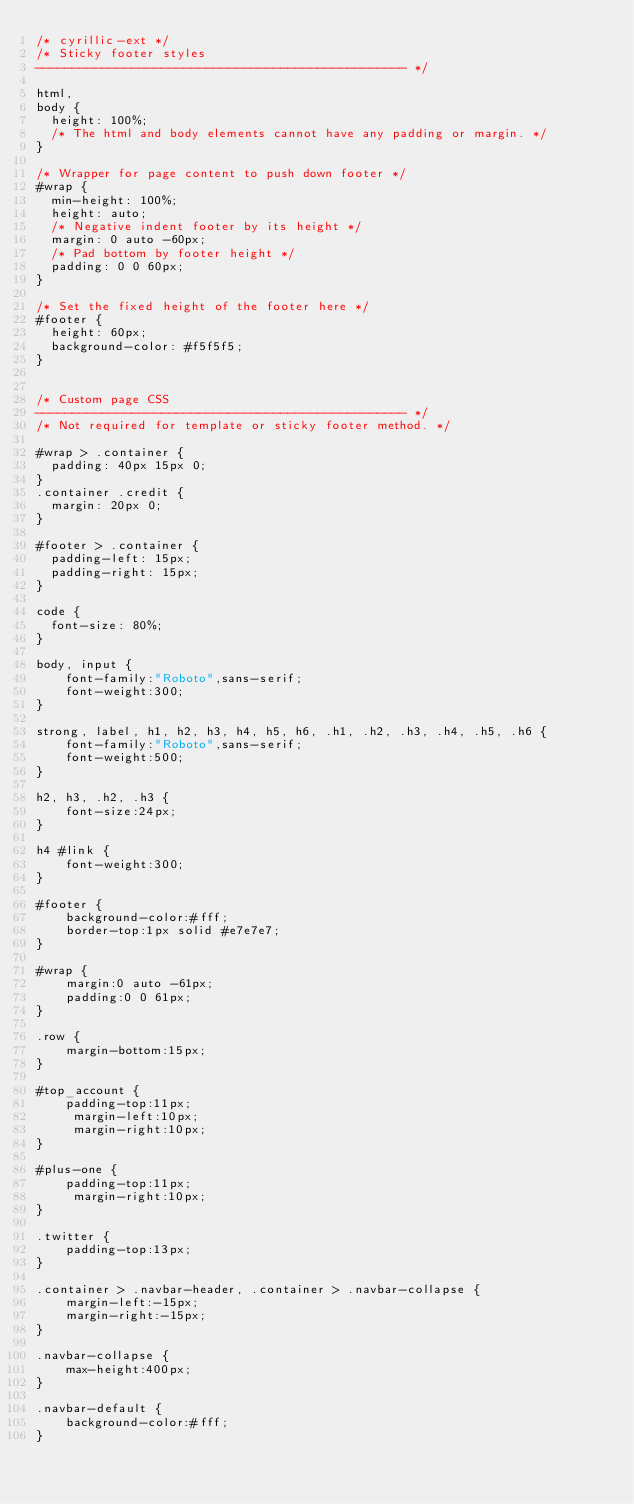<code> <loc_0><loc_0><loc_500><loc_500><_CSS_>/* cyrillic-ext */
/* Sticky footer styles
-------------------------------------------------- */

html,
body {
  height: 100%;
  /* The html and body elements cannot have any padding or margin. */
}

/* Wrapper for page content to push down footer */
#wrap {
  min-height: 100%;
  height: auto;
  /* Negative indent footer by its height */
  margin: 0 auto -60px;
  /* Pad bottom by footer height */
  padding: 0 0 60px;
}

/* Set the fixed height of the footer here */
#footer {
  height: 60px;
  background-color: #f5f5f5;
}


/* Custom page CSS
-------------------------------------------------- */
/* Not required for template or sticky footer method. */

#wrap > .container {
  padding: 40px 15px 0;
}
.container .credit {
  margin: 20px 0;
}

#footer > .container {
  padding-left: 15px;
  padding-right: 15px;
}

code {
  font-size: 80%;
}

body, input {
    font-family:"Roboto",sans-serif;
    font-weight:300;
}

strong, label, h1, h2, h3, h4, h5, h6, .h1, .h2, .h3, .h4, .h5, .h6 {
    font-family:"Roboto",sans-serif;
    font-weight:500;
}

h2, h3, .h2, .h3 {
    font-size:24px;
}

h4 #link {
    font-weight:300;
}

#footer {
    background-color:#fff;
    border-top:1px solid #e7e7e7;
}

#wrap {
    margin:0 auto -61px;
    padding:0 0 61px;
}

.row {
    margin-bottom:15px;
}

#top_account {
    padding-top:11px;
	 margin-left:10px;
	 margin-right:10px;
}

#plus-one {
    padding-top:11px;
	 margin-right:10px;
}

.twitter {
    padding-top:13px;
}

.container > .navbar-header, .container > .navbar-collapse {
    margin-left:-15px;
    margin-right:-15px;
}

.navbar-collapse {
    max-height:400px;
}

.navbar-default {
    background-color:#fff;
}
</code> 